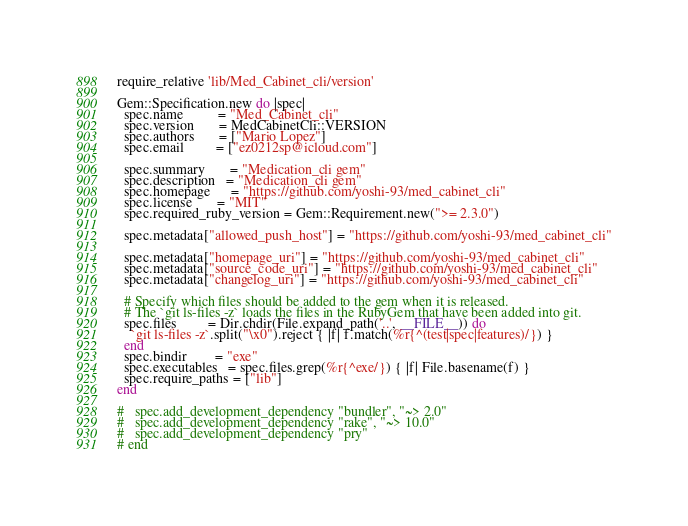Convert code to text. <code><loc_0><loc_0><loc_500><loc_500><_Ruby_>require_relative 'lib/Med_Cabinet_cli/version'

Gem::Specification.new do |spec|
  spec.name          = "Med_Cabinet_cli"
  spec.version       = MedCabinetCli::VERSION
  spec.authors       = ["Mario Lopez"]
  spec.email         = ["ez0212sp@icloud.com"]

  spec.summary       = "Medication_cli gem"
  spec.description   = "Medication_cli gem"
  spec.homepage      = "https://github.com/yoshi-93/med_cabinet_cli"
  spec.license       = "MIT"
  spec.required_ruby_version = Gem::Requirement.new(">= 2.3.0")

  spec.metadata["allowed_push_host"] = "https://github.com/yoshi-93/med_cabinet_cli"

  spec.metadata["homepage_uri"] = "https://github.com/yoshi-93/med_cabinet_cli"
  spec.metadata["source_code_uri"] = "https://github.com/yoshi-93/med_cabinet_cli"
  spec.metadata["changelog_uri"] = "https://github.com/yoshi-93/med_cabinet_cli"

  # Specify which files should be added to the gem when it is released.
  # The `git ls-files -z` loads the files in the RubyGem that have been added into git.
  spec.files         = Dir.chdir(File.expand_path('..', __FILE__)) do
    `git ls-files -z`.split("\x0").reject { |f| f.match(%r{^(test|spec|features)/}) }
  end
  spec.bindir        = "exe"
  spec.executables   = spec.files.grep(%r{^exe/}) { |f| File.basename(f) }
  spec.require_paths = ["lib"]
end
  
#   spec.add_development_dependency "bundler", "~> 2.0"
#   spec.add_development_dependency "rake", "~> 10.0"
#   spec.add_development_dependency "pry"
# end
</code> 